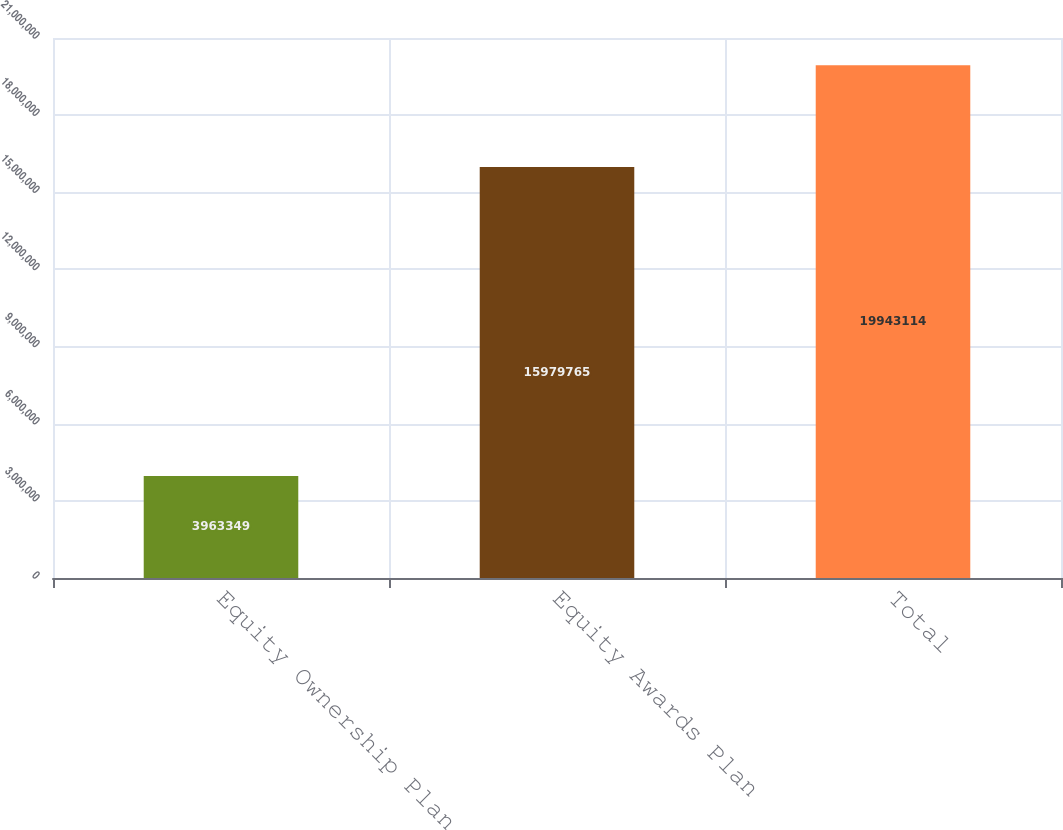Convert chart to OTSL. <chart><loc_0><loc_0><loc_500><loc_500><bar_chart><fcel>Equity Ownership Plan<fcel>Equity Awards Plan<fcel>Total<nl><fcel>3.96335e+06<fcel>1.59798e+07<fcel>1.99431e+07<nl></chart> 